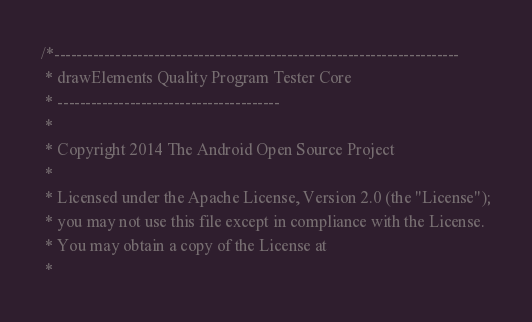<code> <loc_0><loc_0><loc_500><loc_500><_C++_>/*-------------------------------------------------------------------------
 * drawElements Quality Program Tester Core
 * ----------------------------------------
 *
 * Copyright 2014 The Android Open Source Project
 *
 * Licensed under the Apache License, Version 2.0 (the "License");
 * you may not use this file except in compliance with the License.
 * You may obtain a copy of the License at
 *</code> 